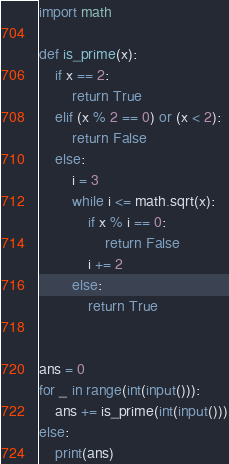Convert code to text. <code><loc_0><loc_0><loc_500><loc_500><_Python_>import math

def is_prime(x):
    if x == 2:
        return True
    elif (x % 2 == 0) or (x < 2):
        return False
    else:
        i = 3
        while i <= math.sqrt(x):
            if x % i == 0:
                return False
            i += 2 
        else:
            return True


ans = 0
for _ in range(int(input())):
    ans += is_prime(int(input()))
else:
    print(ans)
</code> 